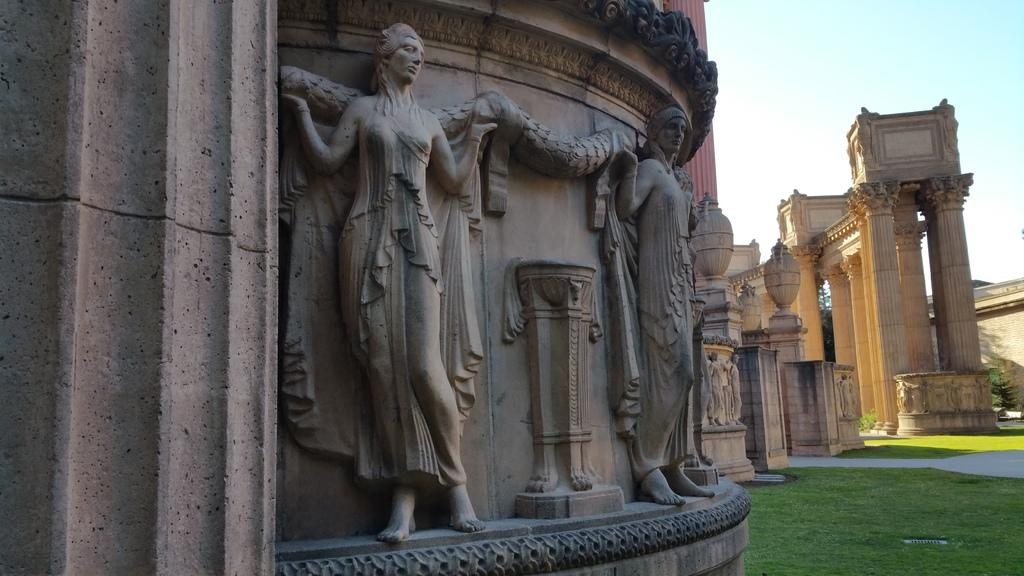What is on the wall in the image? There are sculptures on the wall in the image. What type of vegetation is on the ground? There is grass on the ground. What architectural features can be seen in the background? There are pillars in the background. What is visible in the sky in the image? The sky is visible in the background. What type of pen is being used by the representative in the image? There is no representative or pen present in the image. How many patches can be seen on the grass in the image? There are no patches visible on the grass in the image. 